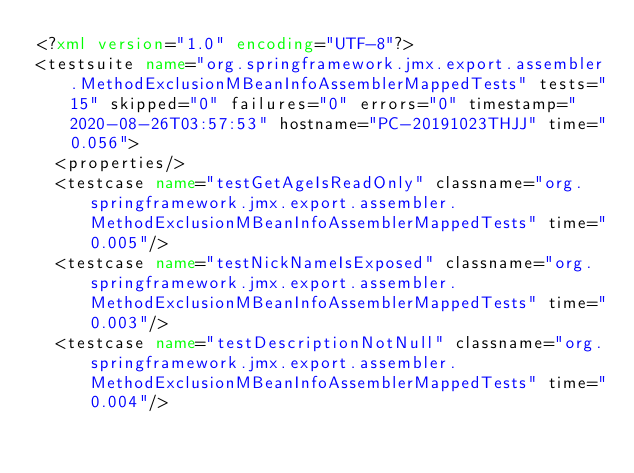Convert code to text. <code><loc_0><loc_0><loc_500><loc_500><_XML_><?xml version="1.0" encoding="UTF-8"?>
<testsuite name="org.springframework.jmx.export.assembler.MethodExclusionMBeanInfoAssemblerMappedTests" tests="15" skipped="0" failures="0" errors="0" timestamp="2020-08-26T03:57:53" hostname="PC-20191023THJJ" time="0.056">
  <properties/>
  <testcase name="testGetAgeIsReadOnly" classname="org.springframework.jmx.export.assembler.MethodExclusionMBeanInfoAssemblerMappedTests" time="0.005"/>
  <testcase name="testNickNameIsExposed" classname="org.springframework.jmx.export.assembler.MethodExclusionMBeanInfoAssemblerMappedTests" time="0.003"/>
  <testcase name="testDescriptionNotNull" classname="org.springframework.jmx.export.assembler.MethodExclusionMBeanInfoAssemblerMappedTests" time="0.004"/></code> 